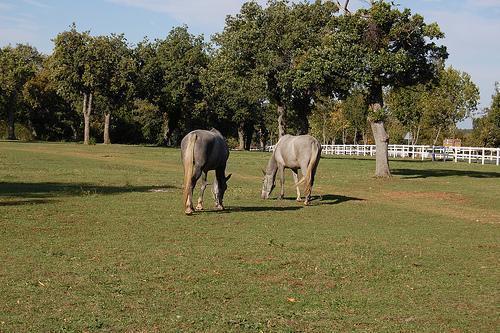How many horses are there?
Give a very brief answer. 2. How many horses are in the picture?
Give a very brief answer. 2. 